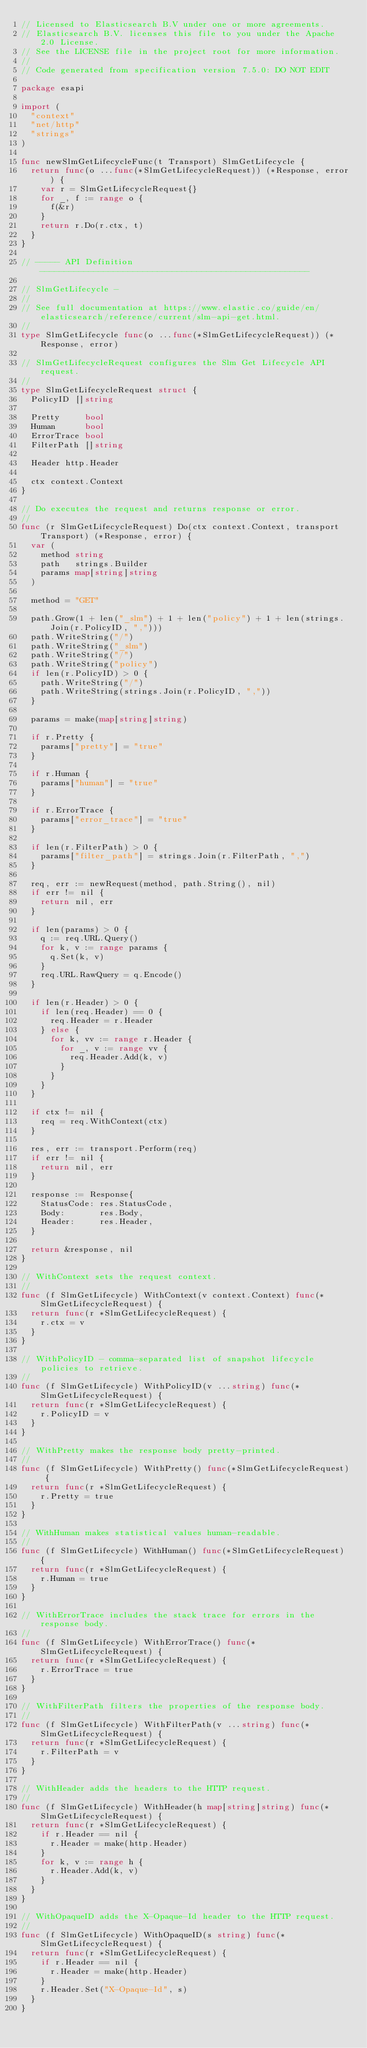<code> <loc_0><loc_0><loc_500><loc_500><_Go_>// Licensed to Elasticsearch B.V under one or more agreements.
// Elasticsearch B.V. licenses this file to you under the Apache 2.0 License.
// See the LICENSE file in the project root for more information.
//
// Code generated from specification version 7.5.0: DO NOT EDIT

package esapi

import (
	"context"
	"net/http"
	"strings"
)

func newSlmGetLifecycleFunc(t Transport) SlmGetLifecycle {
	return func(o ...func(*SlmGetLifecycleRequest)) (*Response, error) {
		var r = SlmGetLifecycleRequest{}
		for _, f := range o {
			f(&r)
		}
		return r.Do(r.ctx, t)
	}
}

// ----- API Definition -------------------------------------------------------

// SlmGetLifecycle -
//
// See full documentation at https://www.elastic.co/guide/en/elasticsearch/reference/current/slm-api-get.html.
//
type SlmGetLifecycle func(o ...func(*SlmGetLifecycleRequest)) (*Response, error)

// SlmGetLifecycleRequest configures the Slm Get Lifecycle API request.
//
type SlmGetLifecycleRequest struct {
	PolicyID []string

	Pretty     bool
	Human      bool
	ErrorTrace bool
	FilterPath []string

	Header http.Header

	ctx context.Context
}

// Do executes the request and returns response or error.
//
func (r SlmGetLifecycleRequest) Do(ctx context.Context, transport Transport) (*Response, error) {
	var (
		method string
		path   strings.Builder
		params map[string]string
	)

	method = "GET"

	path.Grow(1 + len("_slm") + 1 + len("policy") + 1 + len(strings.Join(r.PolicyID, ",")))
	path.WriteString("/")
	path.WriteString("_slm")
	path.WriteString("/")
	path.WriteString("policy")
	if len(r.PolicyID) > 0 {
		path.WriteString("/")
		path.WriteString(strings.Join(r.PolicyID, ","))
	}

	params = make(map[string]string)

	if r.Pretty {
		params["pretty"] = "true"
	}

	if r.Human {
		params["human"] = "true"
	}

	if r.ErrorTrace {
		params["error_trace"] = "true"
	}

	if len(r.FilterPath) > 0 {
		params["filter_path"] = strings.Join(r.FilterPath, ",")
	}

	req, err := newRequest(method, path.String(), nil)
	if err != nil {
		return nil, err
	}

	if len(params) > 0 {
		q := req.URL.Query()
		for k, v := range params {
			q.Set(k, v)
		}
		req.URL.RawQuery = q.Encode()
	}

	if len(r.Header) > 0 {
		if len(req.Header) == 0 {
			req.Header = r.Header
		} else {
			for k, vv := range r.Header {
				for _, v := range vv {
					req.Header.Add(k, v)
				}
			}
		}
	}

	if ctx != nil {
		req = req.WithContext(ctx)
	}

	res, err := transport.Perform(req)
	if err != nil {
		return nil, err
	}

	response := Response{
		StatusCode: res.StatusCode,
		Body:       res.Body,
		Header:     res.Header,
	}

	return &response, nil
}

// WithContext sets the request context.
//
func (f SlmGetLifecycle) WithContext(v context.Context) func(*SlmGetLifecycleRequest) {
	return func(r *SlmGetLifecycleRequest) {
		r.ctx = v
	}
}

// WithPolicyID - comma-separated list of snapshot lifecycle policies to retrieve.
//
func (f SlmGetLifecycle) WithPolicyID(v ...string) func(*SlmGetLifecycleRequest) {
	return func(r *SlmGetLifecycleRequest) {
		r.PolicyID = v
	}
}

// WithPretty makes the response body pretty-printed.
//
func (f SlmGetLifecycle) WithPretty() func(*SlmGetLifecycleRequest) {
	return func(r *SlmGetLifecycleRequest) {
		r.Pretty = true
	}
}

// WithHuman makes statistical values human-readable.
//
func (f SlmGetLifecycle) WithHuman() func(*SlmGetLifecycleRequest) {
	return func(r *SlmGetLifecycleRequest) {
		r.Human = true
	}
}

// WithErrorTrace includes the stack trace for errors in the response body.
//
func (f SlmGetLifecycle) WithErrorTrace() func(*SlmGetLifecycleRequest) {
	return func(r *SlmGetLifecycleRequest) {
		r.ErrorTrace = true
	}
}

// WithFilterPath filters the properties of the response body.
//
func (f SlmGetLifecycle) WithFilterPath(v ...string) func(*SlmGetLifecycleRequest) {
	return func(r *SlmGetLifecycleRequest) {
		r.FilterPath = v
	}
}

// WithHeader adds the headers to the HTTP request.
//
func (f SlmGetLifecycle) WithHeader(h map[string]string) func(*SlmGetLifecycleRequest) {
	return func(r *SlmGetLifecycleRequest) {
		if r.Header == nil {
			r.Header = make(http.Header)
		}
		for k, v := range h {
			r.Header.Add(k, v)
		}
	}
}

// WithOpaqueID adds the X-Opaque-Id header to the HTTP request.
//
func (f SlmGetLifecycle) WithOpaqueID(s string) func(*SlmGetLifecycleRequest) {
	return func(r *SlmGetLifecycleRequest) {
		if r.Header == nil {
			r.Header = make(http.Header)
		}
		r.Header.Set("X-Opaque-Id", s)
	}
}
</code> 